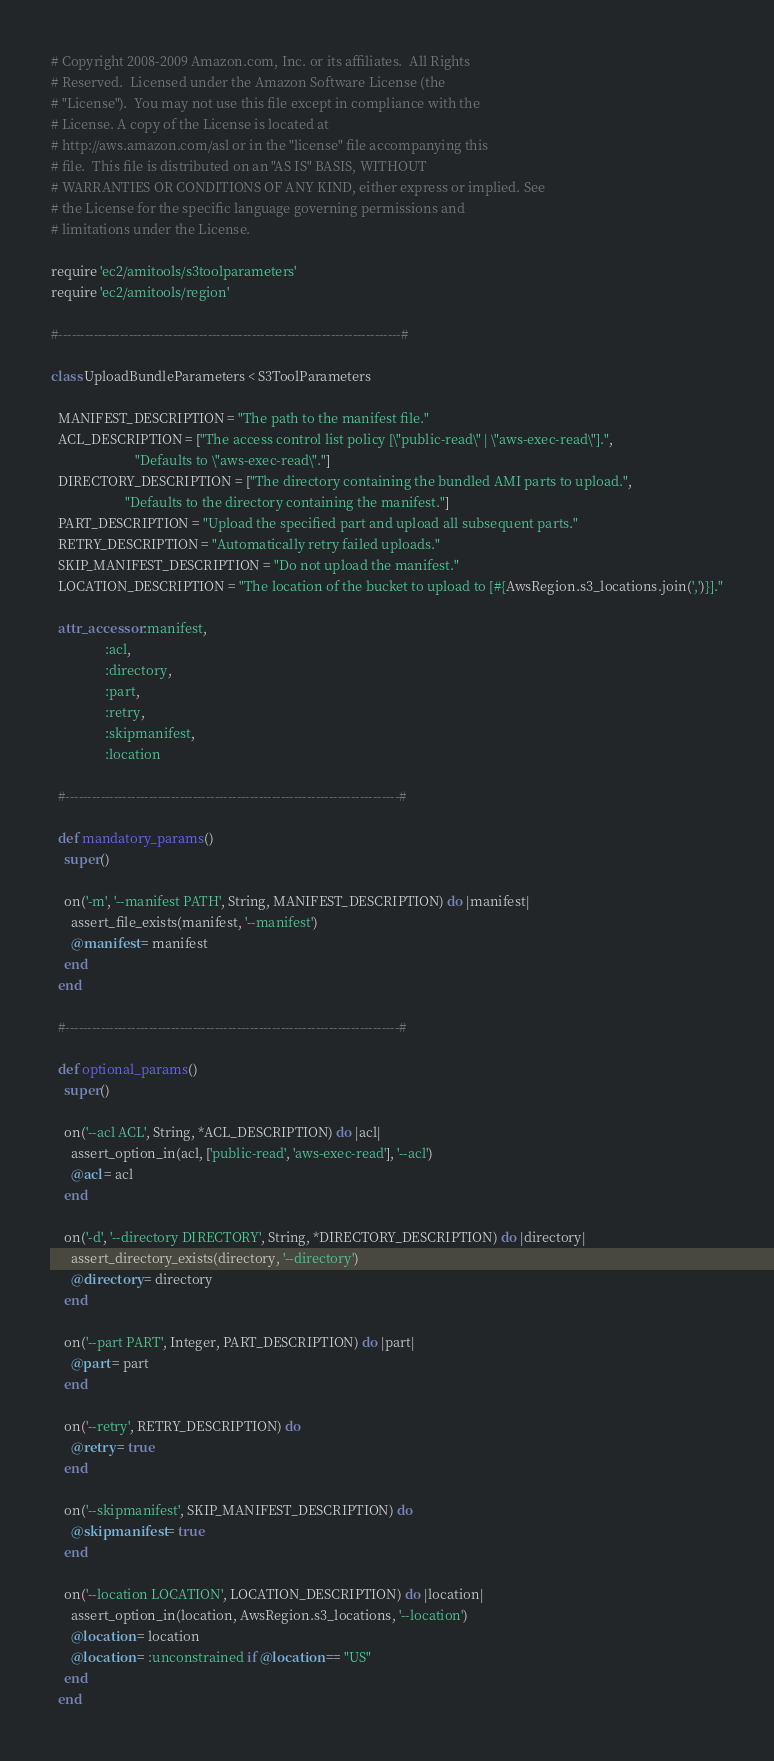<code> <loc_0><loc_0><loc_500><loc_500><_Ruby_># Copyright 2008-2009 Amazon.com, Inc. or its affiliates.  All Rights
# Reserved.  Licensed under the Amazon Software License (the
# "License").  You may not use this file except in compliance with the
# License. A copy of the License is located at
# http://aws.amazon.com/asl or in the "license" file accompanying this
# file.  This file is distributed on an "AS IS" BASIS, WITHOUT
# WARRANTIES OR CONDITIONS OF ANY KIND, either express or implied. See
# the License for the specific language governing permissions and
# limitations under the License.

require 'ec2/amitools/s3toolparameters'
require 'ec2/amitools/region'

#------------------------------------------------------------------------------#

class UploadBundleParameters < S3ToolParameters

  MANIFEST_DESCRIPTION = "The path to the manifest file."
  ACL_DESCRIPTION = ["The access control list policy [\"public-read\" | \"aws-exec-read\"].",
                         "Defaults to \"aws-exec-read\"."]
  DIRECTORY_DESCRIPTION = ["The directory containing the bundled AMI parts to upload.",
                      "Defaults to the directory containing the manifest."]
  PART_DESCRIPTION = "Upload the specified part and upload all subsequent parts."
  RETRY_DESCRIPTION = "Automatically retry failed uploads."
  SKIP_MANIFEST_DESCRIPTION = "Do not upload the manifest."
  LOCATION_DESCRIPTION = "The location of the bucket to upload to [#{AwsRegion.s3_locations.join(',')}]."
  
  attr_accessor :manifest,
                :acl,
                :directory,
                :part,
                :retry,
                :skipmanifest,
                :location

  #----------------------------------------------------------------------------#

  def mandatory_params()
    super()
    
    on('-m', '--manifest PATH', String, MANIFEST_DESCRIPTION) do |manifest|
      assert_file_exists(manifest, '--manifest')
      @manifest = manifest
    end
  end

  #----------------------------------------------------------------------------#

  def optional_params()
    super()
    
    on('--acl ACL', String, *ACL_DESCRIPTION) do |acl|
      assert_option_in(acl, ['public-read', 'aws-exec-read'], '--acl')
      @acl = acl
    end
    
    on('-d', '--directory DIRECTORY', String, *DIRECTORY_DESCRIPTION) do |directory|
      assert_directory_exists(directory, '--directory')
      @directory = directory
    end
    
    on('--part PART', Integer, PART_DESCRIPTION) do |part|
      @part = part
    end
    
    on('--retry', RETRY_DESCRIPTION) do
      @retry = true
    end
    
    on('--skipmanifest', SKIP_MANIFEST_DESCRIPTION) do
      @skipmanifest = true
    end
    
    on('--location LOCATION', LOCATION_DESCRIPTION) do |location|
      assert_option_in(location, AwsRegion.s3_locations, '--location')
      @location = location
      @location = :unconstrained if @location == "US"
    end
  end
</code> 